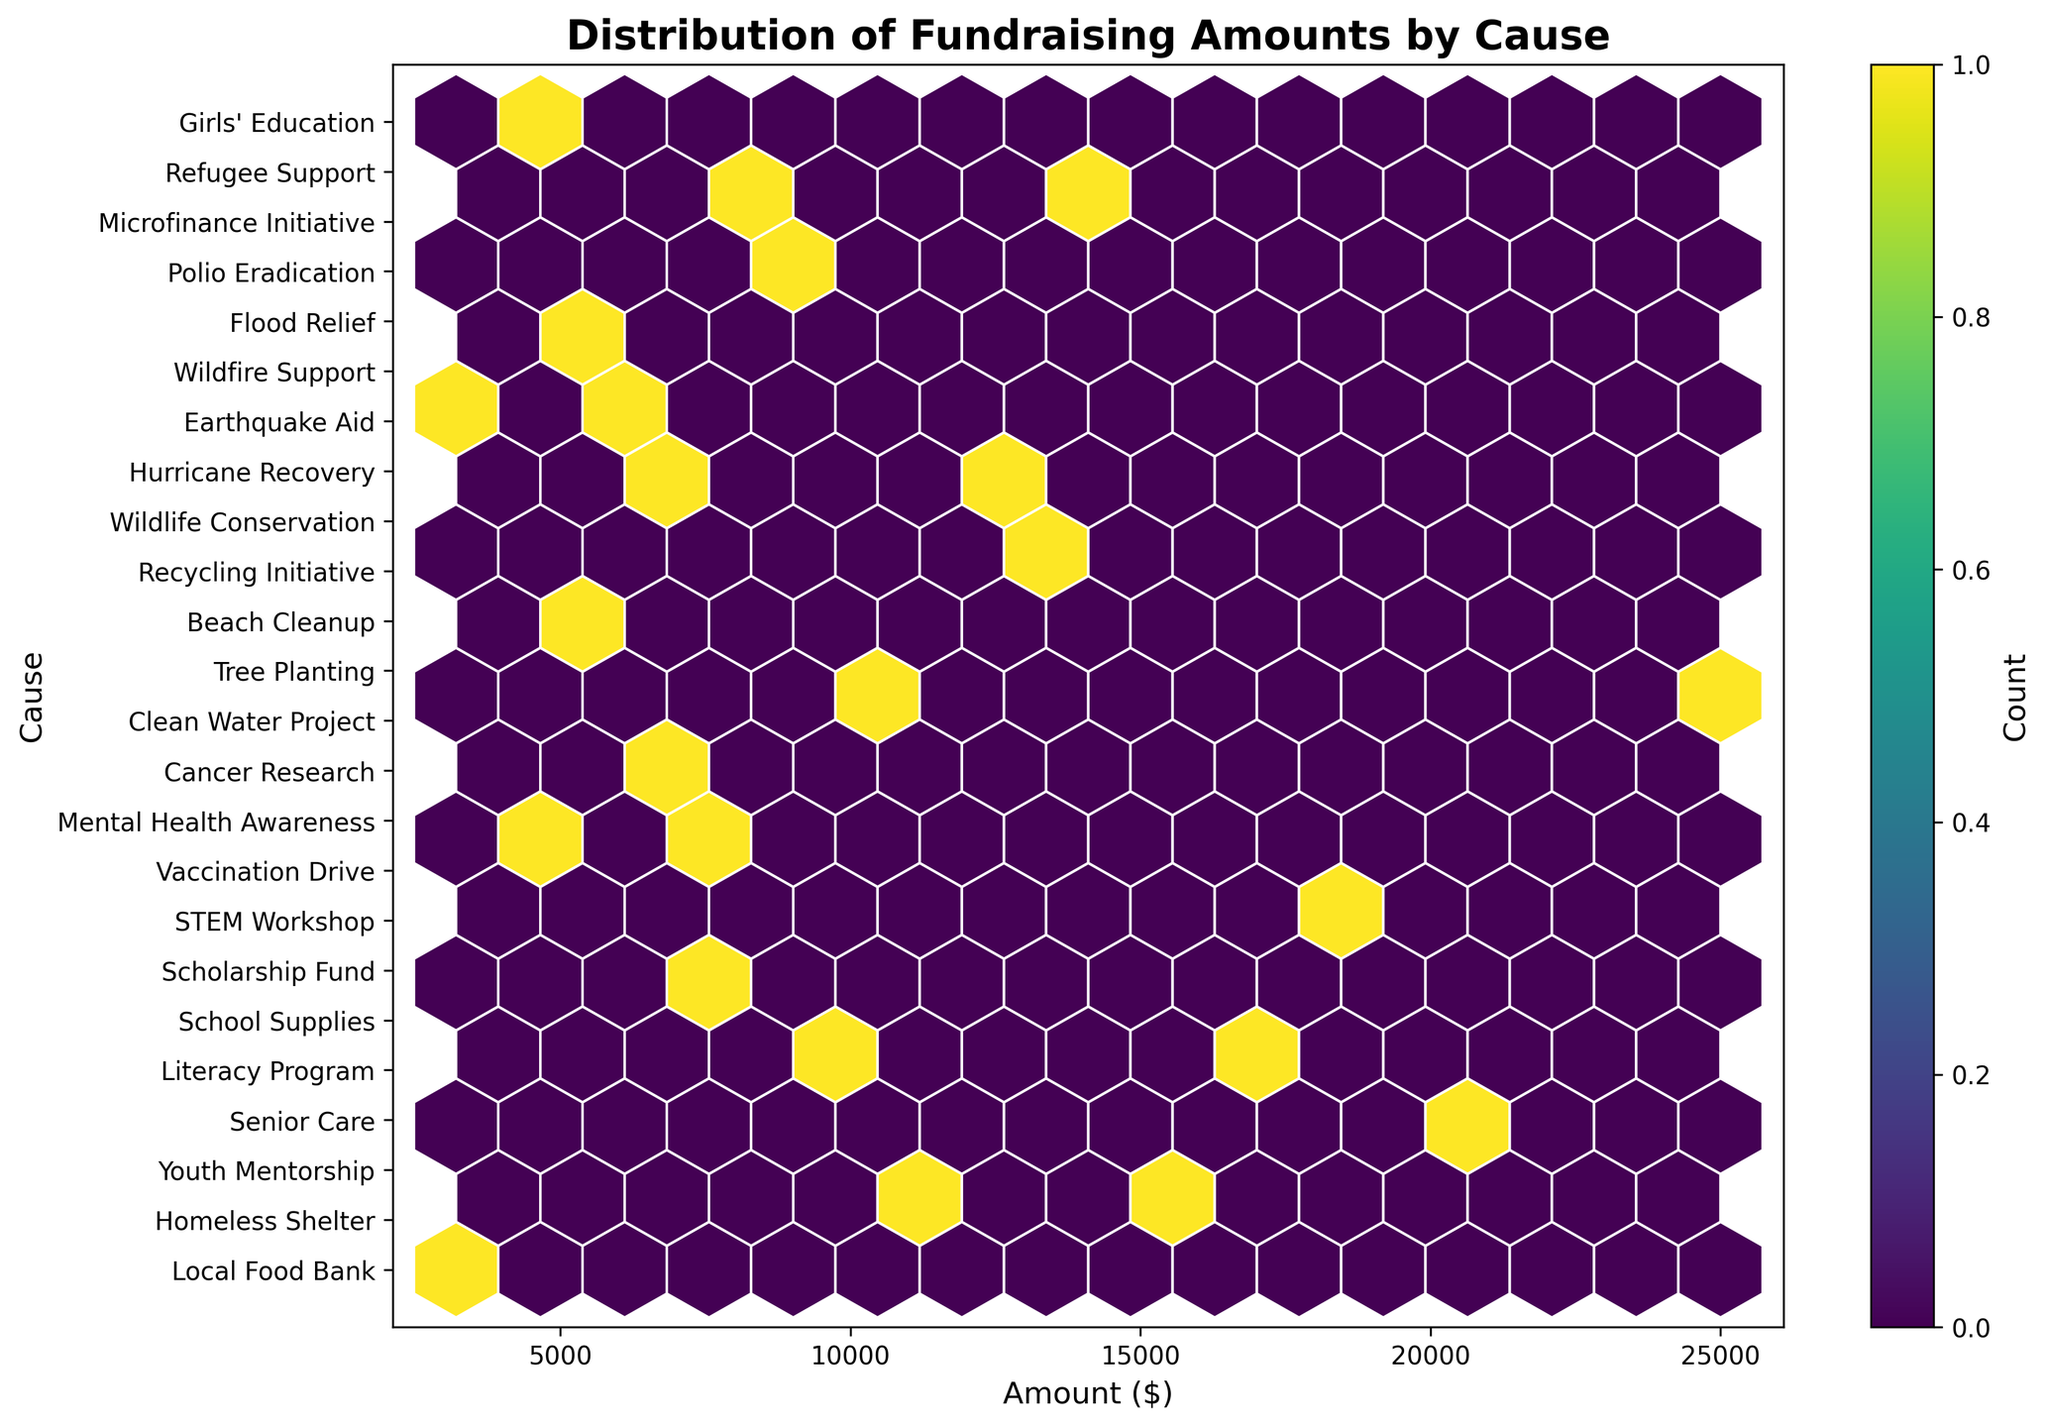What is the title of the plot? The title of the plot is usually placed at the top of the figure and can be read directly.
Answer: Distribution of Fundraising Amounts by Cause What is the range of the x-axis? The x-axis represents the fundraising amounts in dollars and the range is displayed on the axis.
Answer: Approximately 0 to 25000 How many major categories of causes are there in total? The number of unique categories on the y-axis can be counted based on the y-axis labels.
Answer: 8 Which cause appears to have the highest count of fundraising amounts? Look for the y-axis label where the hexbin density is the highest; the highest concentration of hexagons indicates the most frequent cause.
Answer: Earthquake Aid Which category has fundraising amounts up to $25000? Examine the x-axis range for each hexbin's coverage within a single y-axis category to see if any extend up to $25000.
Answer: International Comparing Health and Environment categories, which one has higher fundraising amounts? Identify and compare the position of hexagons (stretch along the x-axis) for both Health and Environment categories.
Answer: Health What are the extreme values of fundraising amounts for the "Disaster Relief" category? Identify the leftmost and rightmost edges of the hexagons in the Disaster Relief category on the y-axis.
Answer: 14000 to 20000 Which category has the widest range of fundraising amounts? Check which y-axis label extends across the widest part of the x-axis.
Answer: Disaster Relief How does the density of fundraising amounts for Community Service compare to Education? Compare the concentration of hexagons between the Community Service and Education categories on the y-axis.
Answer: Community Service has a higher density Which category has a low fundraising amount around $3500? Find the y-axis label aligned with a hexagon close to the $3500 mark on the x-axis.
Answer: Education 